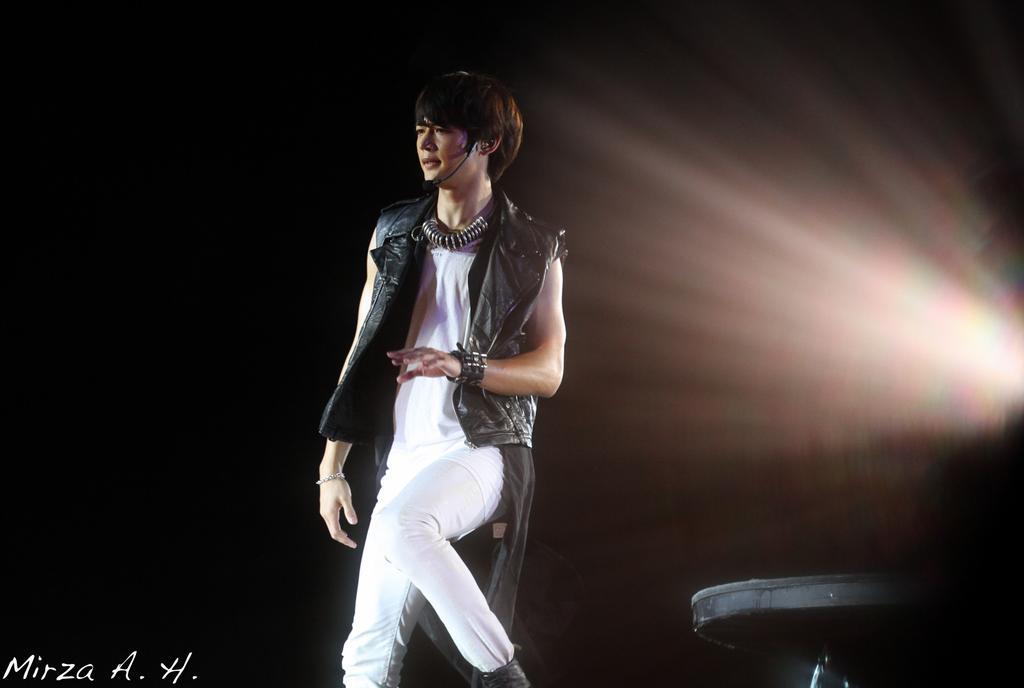In one or two sentences, can you explain what this image depicts? In this image we can see a person wearing the black color jacket and standing and the background of the image is in black color. We can also see the table and also the text in this image. 